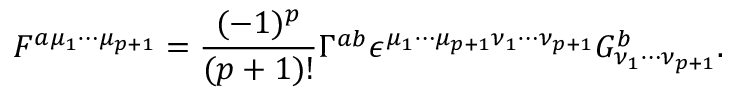<formula> <loc_0><loc_0><loc_500><loc_500>F ^ { a { \mu } _ { 1 } { \cdots } { \mu } _ { p + 1 } } = \frac { ( - 1 ) ^ { p } } { ( p + 1 ) ! } { \Gamma } ^ { a b } { \epsilon } ^ { { \mu } _ { 1 } { \cdots } { \mu } _ { p + 1 } { \nu } _ { 1 } { \cdots } { \nu } _ { p + 1 } } G _ { { \nu } _ { 1 } { \cdots } { \nu } _ { p + 1 } } ^ { b } .</formula> 